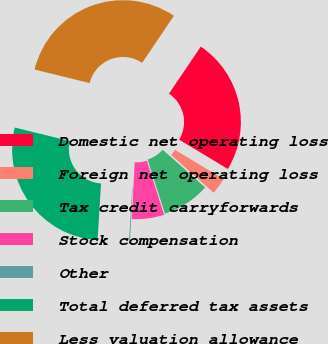Convert chart. <chart><loc_0><loc_0><loc_500><loc_500><pie_chart><fcel>Domestic net operating loss<fcel>Foreign net operating loss<fcel>Tax credit carryforwards<fcel>Stock compensation<fcel>Other<fcel>Total deferred tax assets<fcel>Less valuation allowance<nl><fcel>24.16%<fcel>2.96%<fcel>8.49%<fcel>5.72%<fcel>0.19%<fcel>27.85%<fcel>30.62%<nl></chart> 